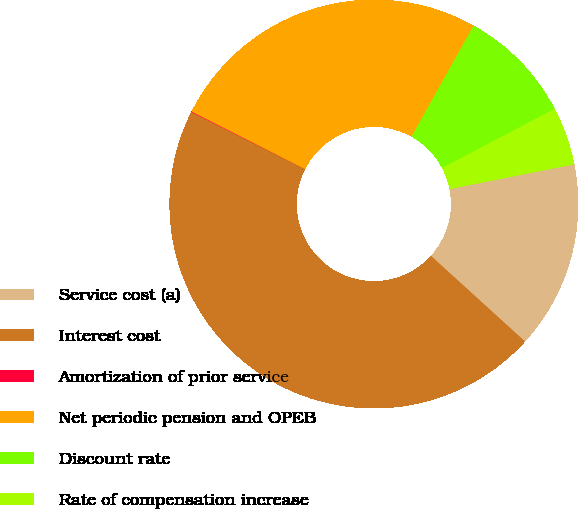<chart> <loc_0><loc_0><loc_500><loc_500><pie_chart><fcel>Service cost (a)<fcel>Interest cost<fcel>Amortization of prior service<fcel>Net periodic pension and OPEB<fcel>Discount rate<fcel>Rate of compensation increase<nl><fcel>14.86%<fcel>45.69%<fcel>0.04%<fcel>25.64%<fcel>9.17%<fcel>4.6%<nl></chart> 